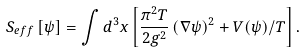Convert formula to latex. <formula><loc_0><loc_0><loc_500><loc_500>S _ { e f f } \left [ \psi \right ] = \int d ^ { 3 } x \left [ \frac { \pi ^ { 2 } T } { 2 g ^ { 2 } } \left ( \nabla \psi \right ) ^ { 2 } + V ( \psi ) / T \right ] .</formula> 